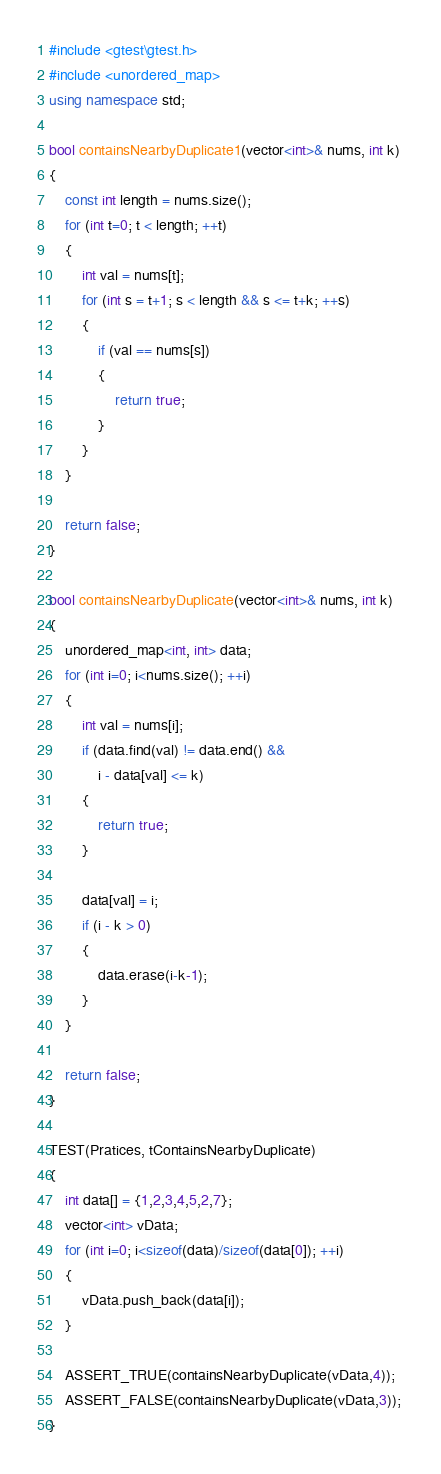Convert code to text. <code><loc_0><loc_0><loc_500><loc_500><_C++_>#include <gtest\gtest.h>
#include <unordered_map>
using namespace std;

bool containsNearbyDuplicate1(vector<int>& nums, int k) 
{
	const int length = nums.size();
	for (int t=0; t < length; ++t)
	{		
		int val = nums[t];
		for (int s = t+1; s < length && s <= t+k; ++s)
		{
			if (val == nums[s])
			{
				return true;
			}
		}
	}

	return false;
}

bool containsNearbyDuplicate(vector<int>& nums, int k) 
{
	unordered_map<int, int> data;
	for (int i=0; i<nums.size(); ++i)
	{
		int val = nums[i];
		if (data.find(val) != data.end() &&
			i - data[val] <= k)
		{
			return true;
		}

		data[val] = i;
		if (i - k > 0)
		{
			data.erase(i-k-1);
		}
	}

	return false;
}

TEST(Pratices, tContainsNearbyDuplicate)
{
	int data[] = {1,2,3,4,5,2,7};
	vector<int> vData;
	for (int i=0; i<sizeof(data)/sizeof(data[0]); ++i)
	{
		vData.push_back(data[i]);
	}

	ASSERT_TRUE(containsNearbyDuplicate(vData,4));
	ASSERT_FALSE(containsNearbyDuplicate(vData,3));
}</code> 